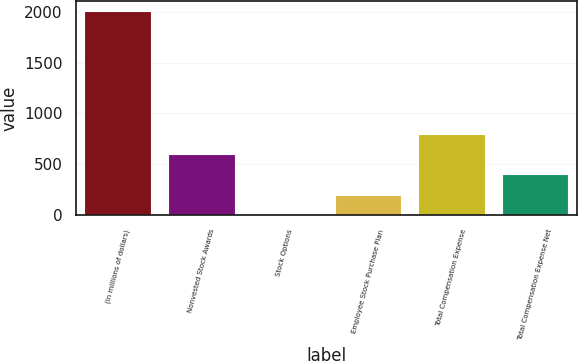Convert chart to OTSL. <chart><loc_0><loc_0><loc_500><loc_500><bar_chart><fcel>(in millions of dollars)<fcel>Nonvested Stock Awards<fcel>Stock Options<fcel>Employee Stock Purchase Plan<fcel>Total Compensation Expense<fcel>Total Compensation Expense Net<nl><fcel>2007<fcel>602.45<fcel>0.5<fcel>201.15<fcel>803.1<fcel>401.8<nl></chart> 